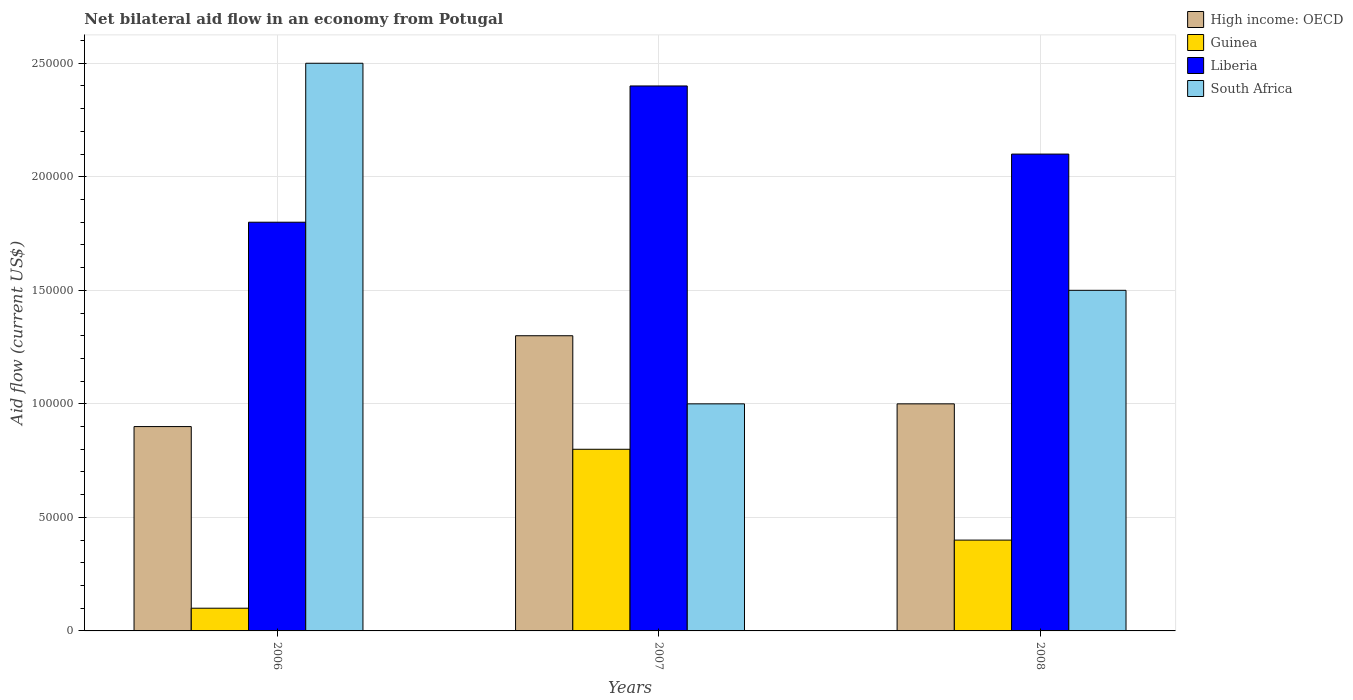How many different coloured bars are there?
Your answer should be compact. 4. Are the number of bars per tick equal to the number of legend labels?
Offer a very short reply. Yes. What is the label of the 3rd group of bars from the left?
Offer a very short reply. 2008. Across all years, what is the minimum net bilateral aid flow in Liberia?
Keep it short and to the point. 1.80e+05. In which year was the net bilateral aid flow in Liberia minimum?
Ensure brevity in your answer.  2006. What is the total net bilateral aid flow in High income: OECD in the graph?
Your response must be concise. 3.20e+05. What is the difference between the net bilateral aid flow in Guinea in 2007 and that in 2008?
Your answer should be compact. 4.00e+04. What is the average net bilateral aid flow in Guinea per year?
Provide a short and direct response. 4.33e+04. In the year 2008, what is the difference between the net bilateral aid flow in Guinea and net bilateral aid flow in Liberia?
Your response must be concise. -1.70e+05. In how many years, is the net bilateral aid flow in High income: OECD greater than 190000 US$?
Give a very brief answer. 0. What is the ratio of the net bilateral aid flow in High income: OECD in 2006 to that in 2008?
Your response must be concise. 0.9. Is the difference between the net bilateral aid flow in Guinea in 2006 and 2008 greater than the difference between the net bilateral aid flow in Liberia in 2006 and 2008?
Offer a terse response. No. What is the difference between the highest and the second highest net bilateral aid flow in High income: OECD?
Keep it short and to the point. 3.00e+04. What is the difference between the highest and the lowest net bilateral aid flow in Guinea?
Keep it short and to the point. 7.00e+04. Is the sum of the net bilateral aid flow in High income: OECD in 2006 and 2007 greater than the maximum net bilateral aid flow in Guinea across all years?
Make the answer very short. Yes. Is it the case that in every year, the sum of the net bilateral aid flow in South Africa and net bilateral aid flow in Liberia is greater than the sum of net bilateral aid flow in High income: OECD and net bilateral aid flow in Guinea?
Give a very brief answer. No. What does the 1st bar from the left in 2008 represents?
Offer a terse response. High income: OECD. What does the 4th bar from the right in 2008 represents?
Your answer should be very brief. High income: OECD. Is it the case that in every year, the sum of the net bilateral aid flow in Liberia and net bilateral aid flow in South Africa is greater than the net bilateral aid flow in Guinea?
Your response must be concise. Yes. How many bars are there?
Ensure brevity in your answer.  12. Are all the bars in the graph horizontal?
Keep it short and to the point. No. How many years are there in the graph?
Your answer should be compact. 3. What is the difference between two consecutive major ticks on the Y-axis?
Give a very brief answer. 5.00e+04. Does the graph contain any zero values?
Ensure brevity in your answer.  No. Does the graph contain grids?
Your answer should be very brief. Yes. How many legend labels are there?
Provide a short and direct response. 4. What is the title of the graph?
Offer a terse response. Net bilateral aid flow in an economy from Potugal. What is the Aid flow (current US$) of High income: OECD in 2006?
Ensure brevity in your answer.  9.00e+04. What is the Aid flow (current US$) of Guinea in 2006?
Offer a terse response. 10000. What is the Aid flow (current US$) of Liberia in 2006?
Ensure brevity in your answer.  1.80e+05. What is the Aid flow (current US$) in High income: OECD in 2007?
Offer a very short reply. 1.30e+05. What is the Aid flow (current US$) in Guinea in 2007?
Provide a short and direct response. 8.00e+04. What is the Aid flow (current US$) in Liberia in 2007?
Make the answer very short. 2.40e+05. What is the Aid flow (current US$) in Guinea in 2008?
Your answer should be very brief. 4.00e+04. What is the Aid flow (current US$) in South Africa in 2008?
Provide a succinct answer. 1.50e+05. Across all years, what is the maximum Aid flow (current US$) of Guinea?
Provide a short and direct response. 8.00e+04. Across all years, what is the maximum Aid flow (current US$) in Liberia?
Your response must be concise. 2.40e+05. Across all years, what is the minimum Aid flow (current US$) of Liberia?
Your answer should be very brief. 1.80e+05. Across all years, what is the minimum Aid flow (current US$) in South Africa?
Offer a very short reply. 1.00e+05. What is the total Aid flow (current US$) of Guinea in the graph?
Your response must be concise. 1.30e+05. What is the total Aid flow (current US$) in Liberia in the graph?
Give a very brief answer. 6.30e+05. What is the total Aid flow (current US$) of South Africa in the graph?
Offer a very short reply. 5.00e+05. What is the difference between the Aid flow (current US$) of Guinea in 2006 and that in 2007?
Your response must be concise. -7.00e+04. What is the difference between the Aid flow (current US$) of Liberia in 2006 and that in 2007?
Make the answer very short. -6.00e+04. What is the difference between the Aid flow (current US$) of South Africa in 2006 and that in 2007?
Ensure brevity in your answer.  1.50e+05. What is the difference between the Aid flow (current US$) of High income: OECD in 2006 and that in 2008?
Your response must be concise. -10000. What is the difference between the Aid flow (current US$) of Liberia in 2006 and that in 2008?
Make the answer very short. -3.00e+04. What is the difference between the Aid flow (current US$) of High income: OECD in 2007 and that in 2008?
Your answer should be compact. 3.00e+04. What is the difference between the Aid flow (current US$) in Guinea in 2007 and that in 2008?
Provide a succinct answer. 4.00e+04. What is the difference between the Aid flow (current US$) in South Africa in 2007 and that in 2008?
Make the answer very short. -5.00e+04. What is the difference between the Aid flow (current US$) of High income: OECD in 2006 and the Aid flow (current US$) of Guinea in 2007?
Offer a terse response. 10000. What is the difference between the Aid flow (current US$) of High income: OECD in 2006 and the Aid flow (current US$) of Liberia in 2007?
Provide a short and direct response. -1.50e+05. What is the difference between the Aid flow (current US$) in Guinea in 2006 and the Aid flow (current US$) in Liberia in 2007?
Offer a terse response. -2.30e+05. What is the difference between the Aid flow (current US$) of Liberia in 2006 and the Aid flow (current US$) of South Africa in 2007?
Keep it short and to the point. 8.00e+04. What is the difference between the Aid flow (current US$) in High income: OECD in 2006 and the Aid flow (current US$) in South Africa in 2008?
Your answer should be very brief. -6.00e+04. What is the difference between the Aid flow (current US$) of Liberia in 2006 and the Aid flow (current US$) of South Africa in 2008?
Make the answer very short. 3.00e+04. What is the difference between the Aid flow (current US$) in High income: OECD in 2007 and the Aid flow (current US$) in Liberia in 2008?
Your answer should be very brief. -8.00e+04. What is the difference between the Aid flow (current US$) in High income: OECD in 2007 and the Aid flow (current US$) in South Africa in 2008?
Ensure brevity in your answer.  -2.00e+04. What is the difference between the Aid flow (current US$) in Guinea in 2007 and the Aid flow (current US$) in Liberia in 2008?
Keep it short and to the point. -1.30e+05. What is the difference between the Aid flow (current US$) in Liberia in 2007 and the Aid flow (current US$) in South Africa in 2008?
Ensure brevity in your answer.  9.00e+04. What is the average Aid flow (current US$) in High income: OECD per year?
Your answer should be compact. 1.07e+05. What is the average Aid flow (current US$) of Guinea per year?
Make the answer very short. 4.33e+04. What is the average Aid flow (current US$) of South Africa per year?
Your answer should be very brief. 1.67e+05. In the year 2006, what is the difference between the Aid flow (current US$) in High income: OECD and Aid flow (current US$) in South Africa?
Your response must be concise. -1.60e+05. In the year 2006, what is the difference between the Aid flow (current US$) of Guinea and Aid flow (current US$) of Liberia?
Keep it short and to the point. -1.70e+05. In the year 2006, what is the difference between the Aid flow (current US$) of Liberia and Aid flow (current US$) of South Africa?
Your answer should be very brief. -7.00e+04. In the year 2007, what is the difference between the Aid flow (current US$) of High income: OECD and Aid flow (current US$) of Guinea?
Offer a terse response. 5.00e+04. In the year 2007, what is the difference between the Aid flow (current US$) in High income: OECD and Aid flow (current US$) in South Africa?
Keep it short and to the point. 3.00e+04. In the year 2007, what is the difference between the Aid flow (current US$) of Guinea and Aid flow (current US$) of South Africa?
Ensure brevity in your answer.  -2.00e+04. In the year 2007, what is the difference between the Aid flow (current US$) of Liberia and Aid flow (current US$) of South Africa?
Offer a very short reply. 1.40e+05. In the year 2008, what is the difference between the Aid flow (current US$) of High income: OECD and Aid flow (current US$) of Guinea?
Your response must be concise. 6.00e+04. In the year 2008, what is the difference between the Aid flow (current US$) of High income: OECD and Aid flow (current US$) of Liberia?
Provide a succinct answer. -1.10e+05. In the year 2008, what is the difference between the Aid flow (current US$) in High income: OECD and Aid flow (current US$) in South Africa?
Your response must be concise. -5.00e+04. In the year 2008, what is the difference between the Aid flow (current US$) of Guinea and Aid flow (current US$) of Liberia?
Ensure brevity in your answer.  -1.70e+05. In the year 2008, what is the difference between the Aid flow (current US$) of Guinea and Aid flow (current US$) of South Africa?
Provide a succinct answer. -1.10e+05. In the year 2008, what is the difference between the Aid flow (current US$) in Liberia and Aid flow (current US$) in South Africa?
Give a very brief answer. 6.00e+04. What is the ratio of the Aid flow (current US$) of High income: OECD in 2006 to that in 2007?
Provide a succinct answer. 0.69. What is the ratio of the Aid flow (current US$) of Liberia in 2006 to that in 2007?
Keep it short and to the point. 0.75. What is the ratio of the Aid flow (current US$) in South Africa in 2006 to that in 2007?
Provide a short and direct response. 2.5. What is the ratio of the Aid flow (current US$) of Guinea in 2006 to that in 2008?
Provide a short and direct response. 0.25. What is the ratio of the Aid flow (current US$) in Liberia in 2006 to that in 2008?
Ensure brevity in your answer.  0.86. What is the ratio of the Aid flow (current US$) in High income: OECD in 2007 to that in 2008?
Offer a very short reply. 1.3. What is the ratio of the Aid flow (current US$) in Liberia in 2007 to that in 2008?
Give a very brief answer. 1.14. What is the ratio of the Aid flow (current US$) in South Africa in 2007 to that in 2008?
Your answer should be compact. 0.67. What is the difference between the highest and the lowest Aid flow (current US$) in High income: OECD?
Keep it short and to the point. 4.00e+04. What is the difference between the highest and the lowest Aid flow (current US$) in Liberia?
Your response must be concise. 6.00e+04. 